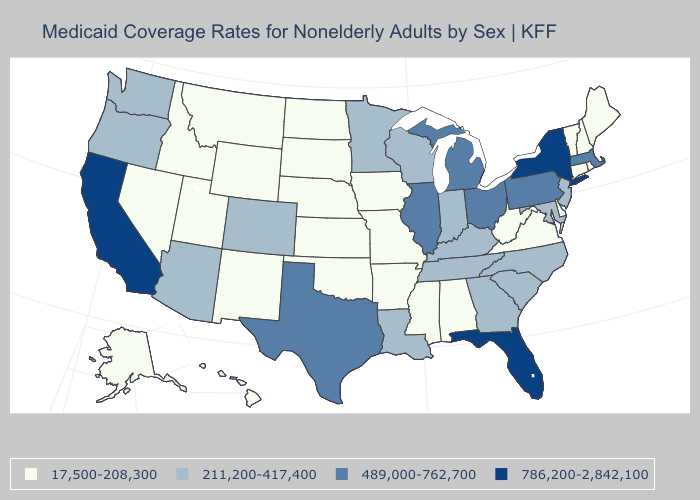Which states have the lowest value in the USA?
Short answer required. Alabama, Alaska, Arkansas, Connecticut, Delaware, Hawaii, Idaho, Iowa, Kansas, Maine, Mississippi, Missouri, Montana, Nebraska, Nevada, New Hampshire, New Mexico, North Dakota, Oklahoma, Rhode Island, South Dakota, Utah, Vermont, Virginia, West Virginia, Wyoming. Name the states that have a value in the range 17,500-208,300?
Quick response, please. Alabama, Alaska, Arkansas, Connecticut, Delaware, Hawaii, Idaho, Iowa, Kansas, Maine, Mississippi, Missouri, Montana, Nebraska, Nevada, New Hampshire, New Mexico, North Dakota, Oklahoma, Rhode Island, South Dakota, Utah, Vermont, Virginia, West Virginia, Wyoming. What is the lowest value in states that border Kentucky?
Give a very brief answer. 17,500-208,300. What is the value of Maine?
Write a very short answer. 17,500-208,300. Among the states that border New Mexico , which have the lowest value?
Concise answer only. Oklahoma, Utah. What is the highest value in the USA?
Keep it brief. 786,200-2,842,100. Name the states that have a value in the range 17,500-208,300?
Write a very short answer. Alabama, Alaska, Arkansas, Connecticut, Delaware, Hawaii, Idaho, Iowa, Kansas, Maine, Mississippi, Missouri, Montana, Nebraska, Nevada, New Hampshire, New Mexico, North Dakota, Oklahoma, Rhode Island, South Dakota, Utah, Vermont, Virginia, West Virginia, Wyoming. What is the value of Hawaii?
Short answer required. 17,500-208,300. What is the highest value in the West ?
Write a very short answer. 786,200-2,842,100. Name the states that have a value in the range 489,000-762,700?
Concise answer only. Illinois, Massachusetts, Michigan, Ohio, Pennsylvania, Texas. Does California have the lowest value in the USA?
Be succinct. No. What is the highest value in the West ?
Be succinct. 786,200-2,842,100. Does California have the highest value in the USA?
Answer briefly. Yes. Name the states that have a value in the range 211,200-417,400?
Concise answer only. Arizona, Colorado, Georgia, Indiana, Kentucky, Louisiana, Maryland, Minnesota, New Jersey, North Carolina, Oregon, South Carolina, Tennessee, Washington, Wisconsin. Name the states that have a value in the range 489,000-762,700?
Concise answer only. Illinois, Massachusetts, Michigan, Ohio, Pennsylvania, Texas. 